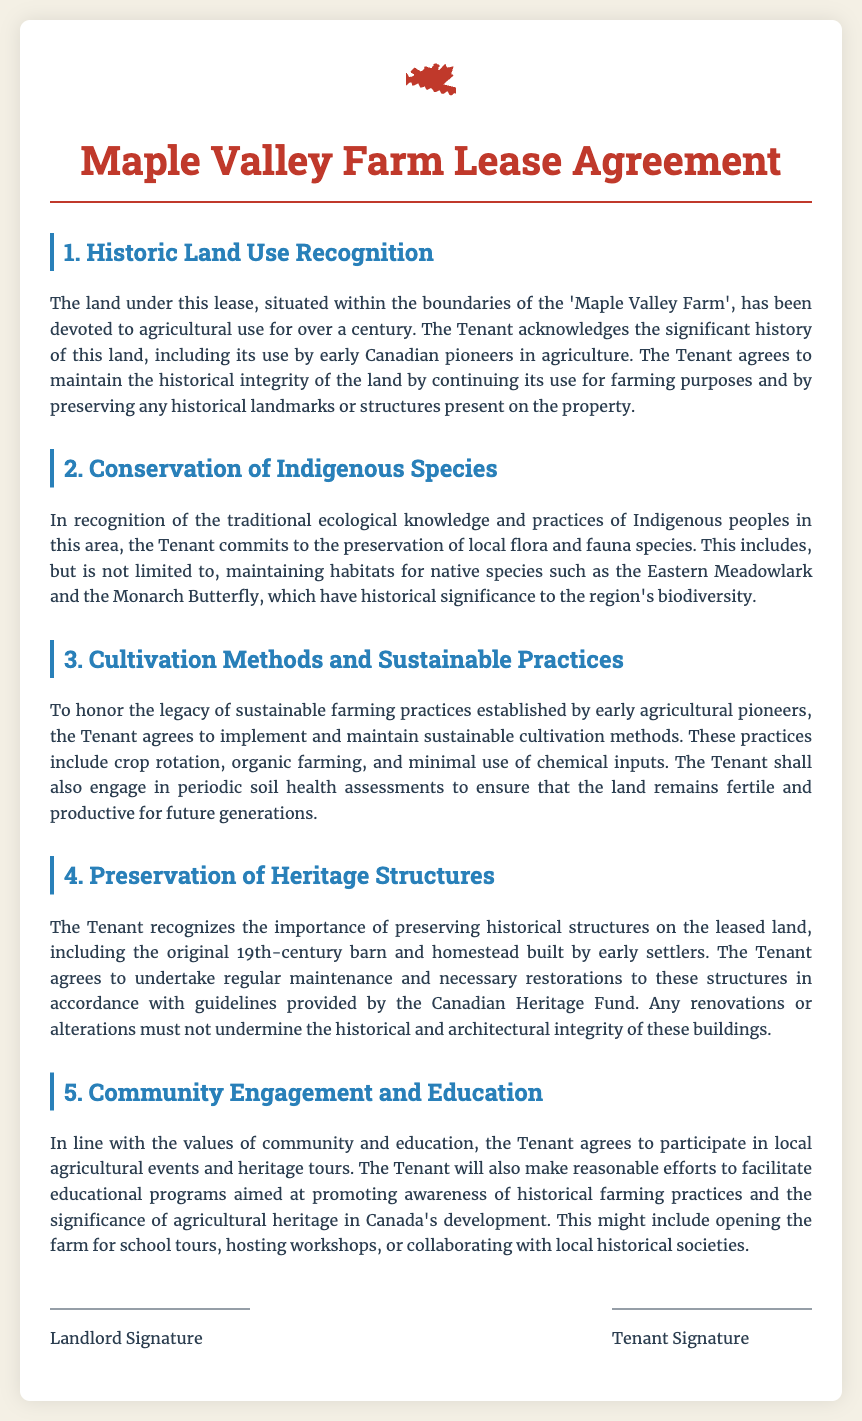What is the name of the farm in the lease agreement? The name of the farm is stated in the title of the document, which is "Maple Valley Farm Lease Agreement."
Answer: Maple Valley Farm How long has the land been devoted to agricultural use? The document explicitly states that the land has been devoted to agricultural use for over a century.
Answer: Over a century Which indigenous species are mentioned in the preservation clause? The preservation clause lists specific species that the Tenant commits to preserving. The species mentioned include the Eastern Meadowlark and the Monarch Butterfly.
Answer: Eastern Meadowlark, Monarch Butterfly What structure is specifically mentioned for preservation? The document refers to a specific structure that must be preserved, which is the original barn built by early settlers.
Answer: 19th-century barn What sustainable practice must the Tenant implement? The document outlines several sustainable practices, one of which is crop rotation.
Answer: Crop rotation Why should the Tenant facilitate educational programs? The reasoning provided in the document states this is to promote awareness of historical farming practices and agricultural heritage.
Answer: Promote awareness What guidelines must the Tenant follow for renovations? The Tenant must adhere to guidelines provided by the Canadian Heritage Fund regarding renovations or alterations.
Answer: Canadian Heritage Fund What type of events should the Tenant participate in? The Tenant is expected to participate in local agricultural events and heritage tours.
Answer: Local agricultural events What decade does the historical structure mentioned date back to? The historical structure referred to in the preservation clause dates back to the 19th century.
Answer: 19th century 